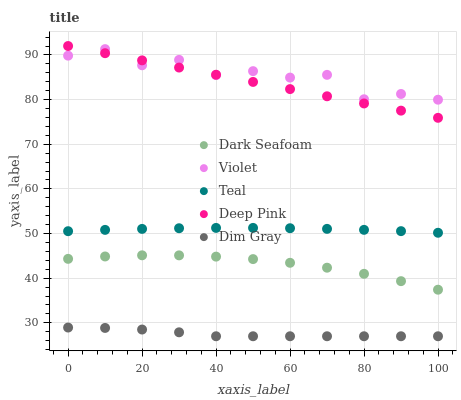Does Dim Gray have the minimum area under the curve?
Answer yes or no. Yes. Does Violet have the maximum area under the curve?
Answer yes or no. Yes. Does Dark Seafoam have the minimum area under the curve?
Answer yes or no. No. Does Dark Seafoam have the maximum area under the curve?
Answer yes or no. No. Is Deep Pink the smoothest?
Answer yes or no. Yes. Is Violet the roughest?
Answer yes or no. Yes. Is Dark Seafoam the smoothest?
Answer yes or no. No. Is Dark Seafoam the roughest?
Answer yes or no. No. Does Dim Gray have the lowest value?
Answer yes or no. Yes. Does Dark Seafoam have the lowest value?
Answer yes or no. No. Does Deep Pink have the highest value?
Answer yes or no. Yes. Does Dark Seafoam have the highest value?
Answer yes or no. No. Is Teal less than Deep Pink?
Answer yes or no. Yes. Is Deep Pink greater than Dim Gray?
Answer yes or no. Yes. Does Violet intersect Deep Pink?
Answer yes or no. Yes. Is Violet less than Deep Pink?
Answer yes or no. No. Is Violet greater than Deep Pink?
Answer yes or no. No. Does Teal intersect Deep Pink?
Answer yes or no. No. 